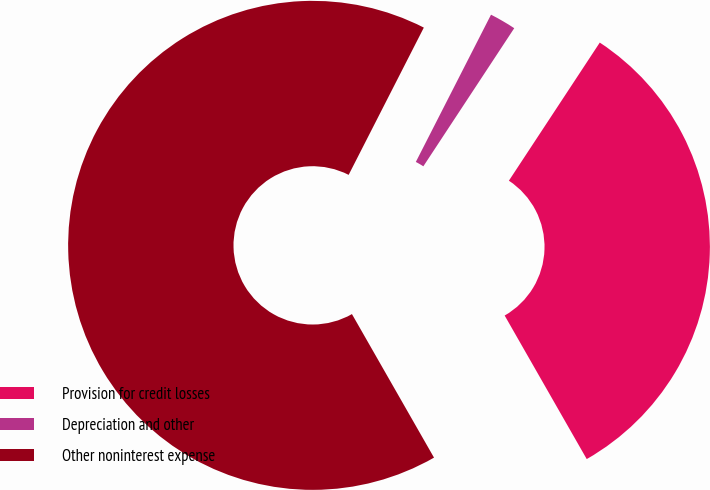Convert chart. <chart><loc_0><loc_0><loc_500><loc_500><pie_chart><fcel>Provision for credit losses<fcel>Depreciation and other<fcel>Other noninterest expense<nl><fcel>32.47%<fcel>1.75%<fcel>65.78%<nl></chart> 